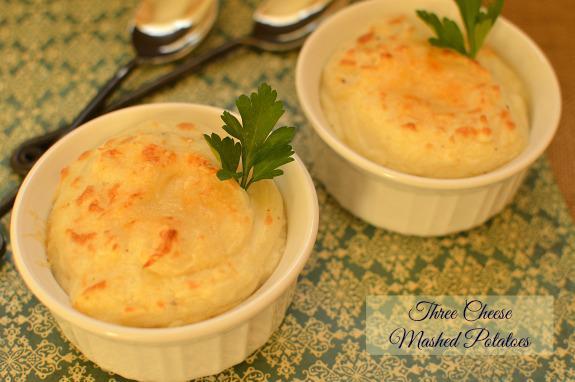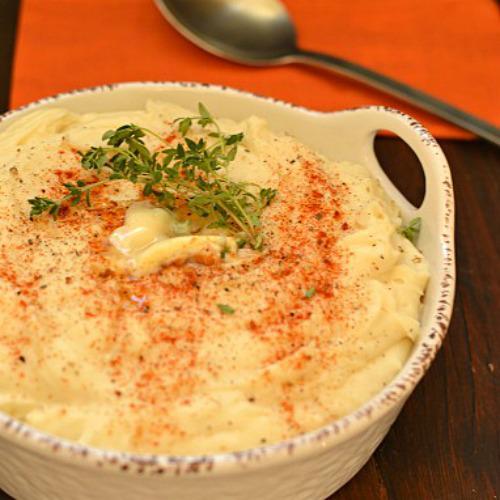The first image is the image on the left, the second image is the image on the right. Evaluate the accuracy of this statement regarding the images: "All images include an item of silverware by a prepared potato dish.". Is it true? Answer yes or no. Yes. 